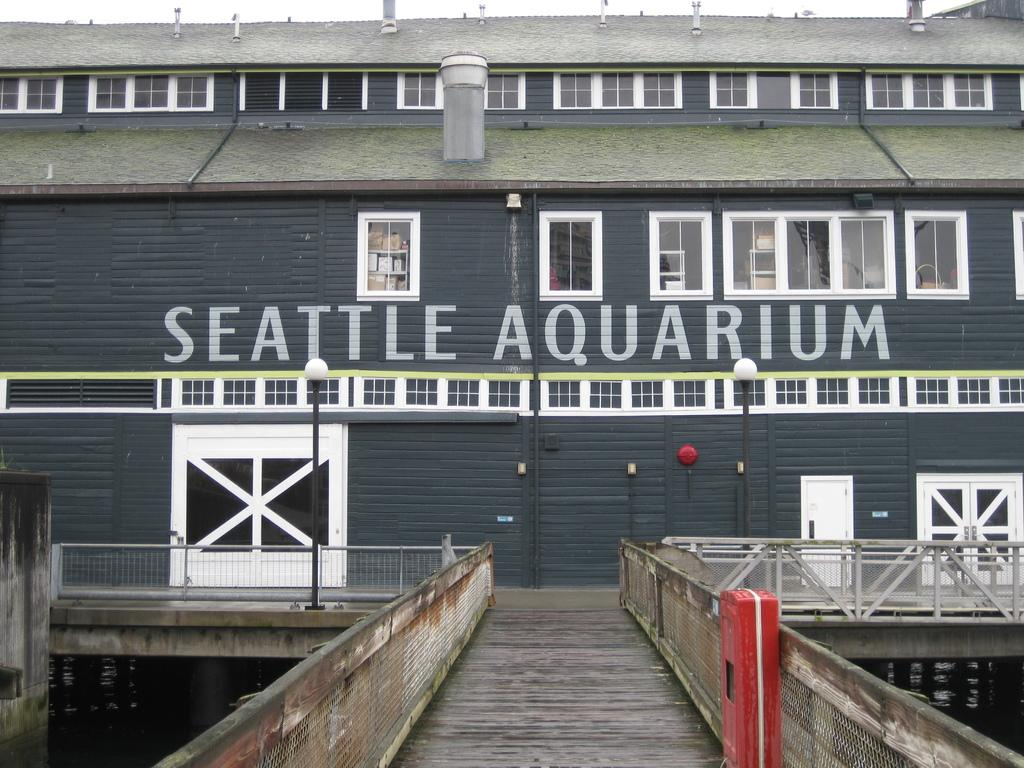What type of structure is visible in the image? There is a building in the image. What feature can be observed on the building? The building has glass windows. What are the light sources in the image? There are light-poles in the image. What type of barrier is present in the image? There is fencing in the image. What can be used to enter or exit the building? There are doors in the image. What color is the object located in front of the building? There is a red color object in front of the building. Can you see any chess pieces being played on the building's roof in the image? There are no chess pieces or any indication of a game being played on the building's roof in the image. 